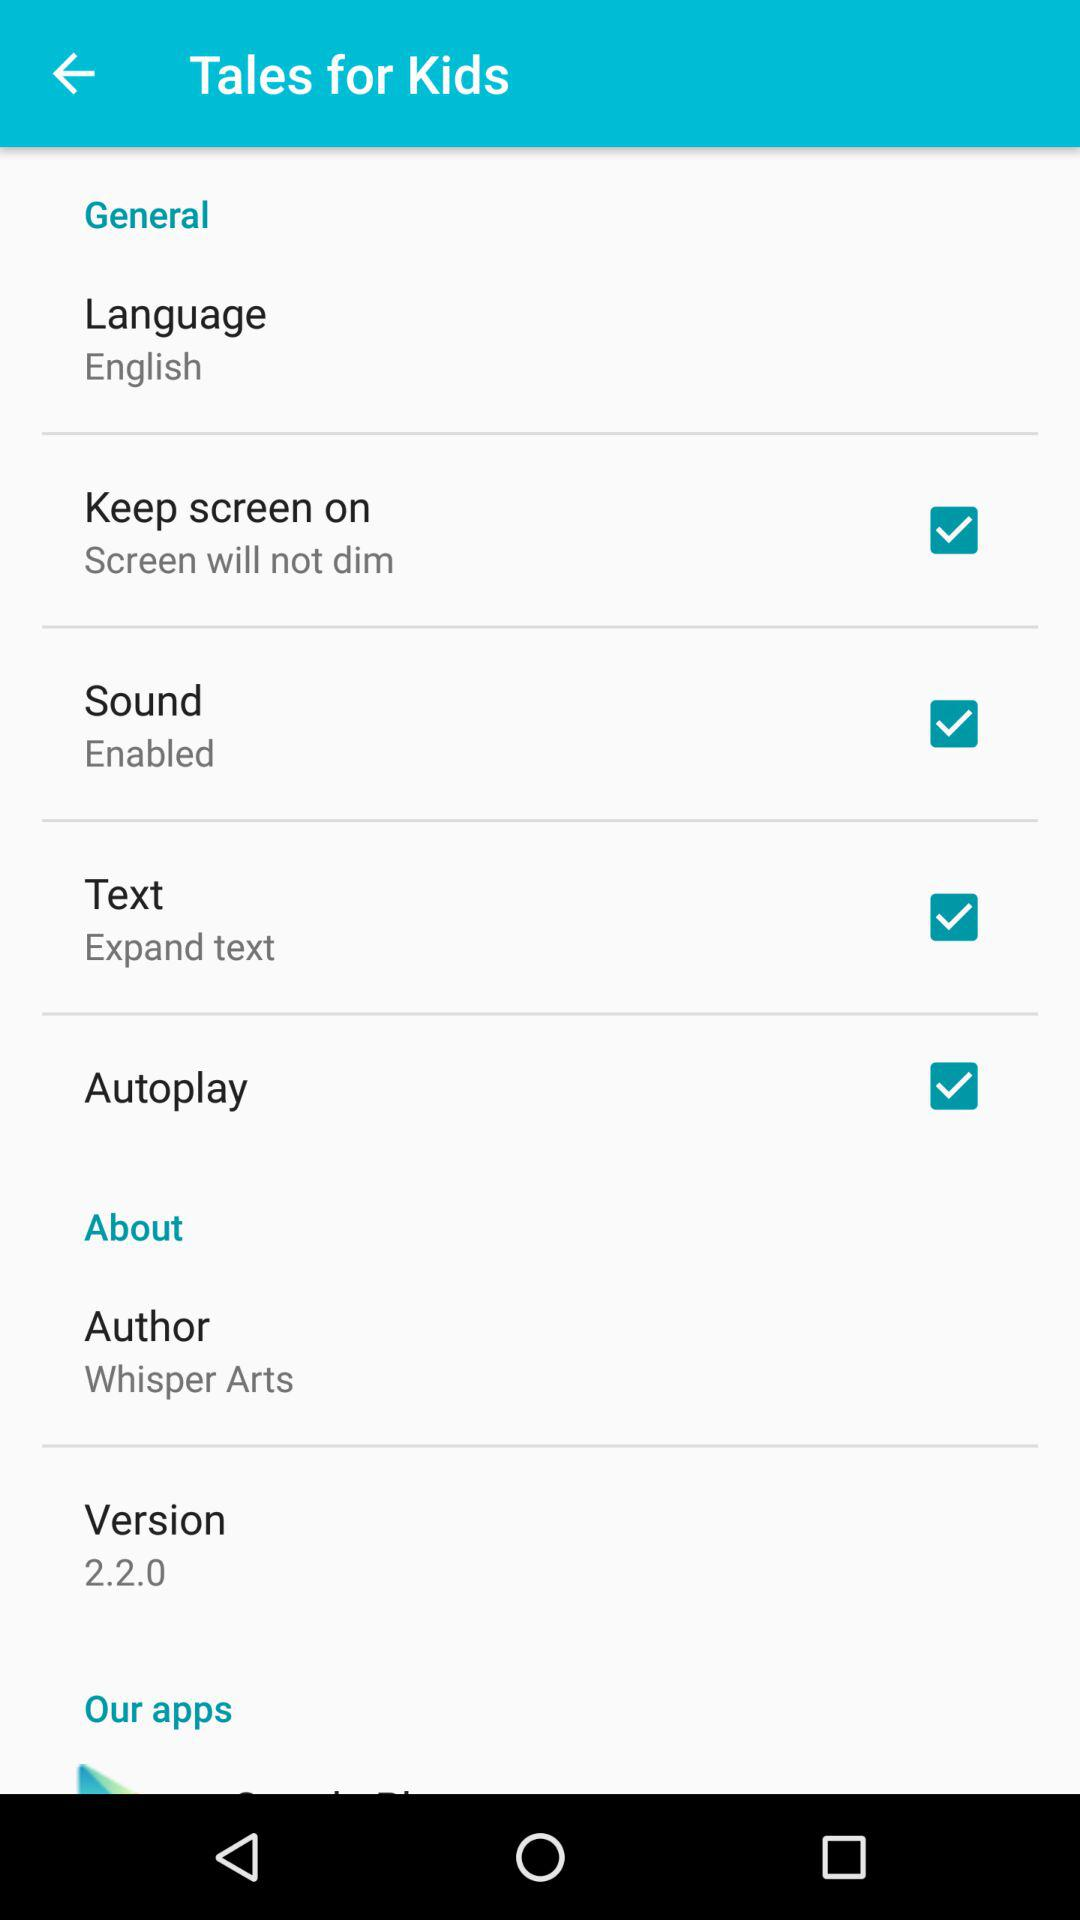Who is the author? The author is Whisper Arts. 